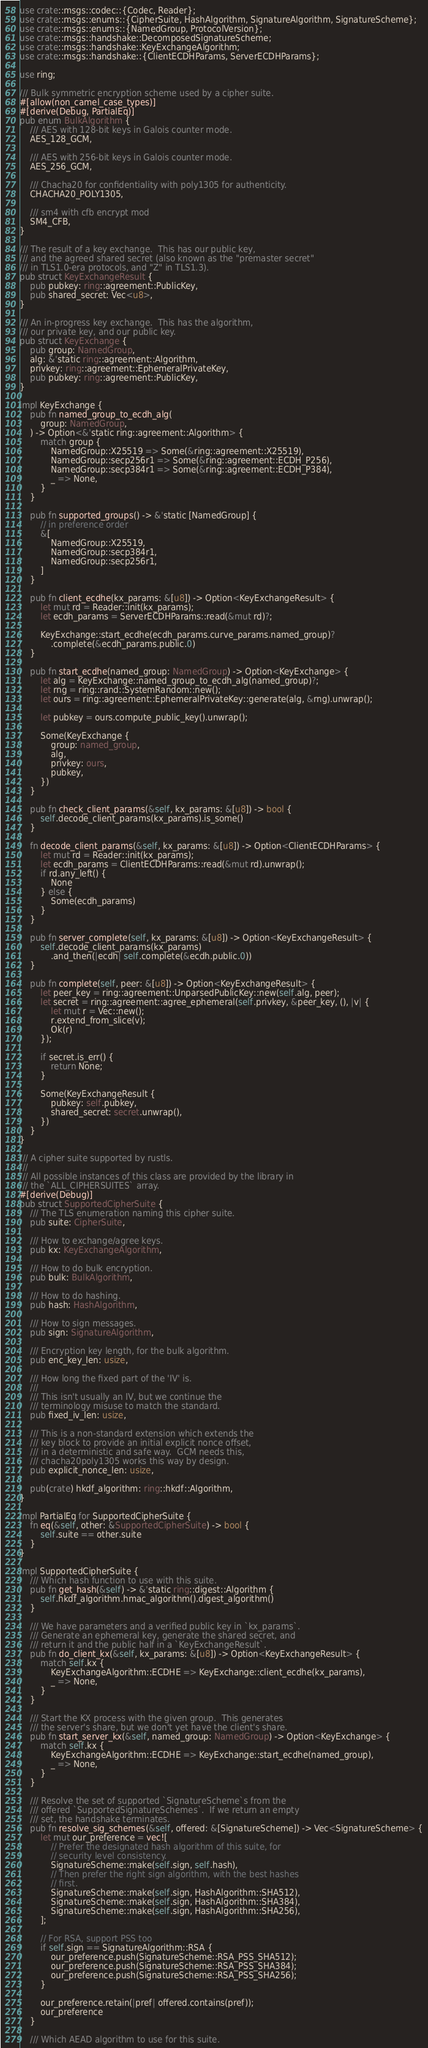Convert code to text. <code><loc_0><loc_0><loc_500><loc_500><_Rust_>use crate::msgs::codec::{Codec, Reader};
use crate::msgs::enums::{CipherSuite, HashAlgorithm, SignatureAlgorithm, SignatureScheme};
use crate::msgs::enums::{NamedGroup, ProtocolVersion};
use crate::msgs::handshake::DecomposedSignatureScheme;
use crate::msgs::handshake::KeyExchangeAlgorithm;
use crate::msgs::handshake::{ClientECDHParams, ServerECDHParams};

use ring;

/// Bulk symmetric encryption scheme used by a cipher suite.
#[allow(non_camel_case_types)]
#[derive(Debug, PartialEq)]
pub enum BulkAlgorithm {
    /// AES with 128-bit keys in Galois counter mode.
    AES_128_GCM,

    /// AES with 256-bit keys in Galois counter mode.
    AES_256_GCM,

    /// Chacha20 for confidentiality with poly1305 for authenticity.
    CHACHA20_POLY1305,

    /// sm4 with cfb encrypt mod
    SM4_CFB,
}

/// The result of a key exchange.  This has our public key,
/// and the agreed shared secret (also known as the "premaster secret"
/// in TLS1.0-era protocols, and "Z" in TLS1.3).
pub struct KeyExchangeResult {
    pub pubkey: ring::agreement::PublicKey,
    pub shared_secret: Vec<u8>,
}

/// An in-progress key exchange.  This has the algorithm,
/// our private key, and our public key.
pub struct KeyExchange {
    pub group: NamedGroup,
    alg: &'static ring::agreement::Algorithm,
    privkey: ring::agreement::EphemeralPrivateKey,
    pub pubkey: ring::agreement::PublicKey,
}

impl KeyExchange {
    pub fn named_group_to_ecdh_alg(
        group: NamedGroup,
    ) -> Option<&'static ring::agreement::Algorithm> {
        match group {
            NamedGroup::X25519 => Some(&ring::agreement::X25519),
            NamedGroup::secp256r1 => Some(&ring::agreement::ECDH_P256),
            NamedGroup::secp384r1 => Some(&ring::agreement::ECDH_P384),
            _ => None,
        }
    }

    pub fn supported_groups() -> &'static [NamedGroup] {
        // in preference order
        &[
            NamedGroup::X25519,
            NamedGroup::secp384r1,
            NamedGroup::secp256r1,
        ]
    }

    pub fn client_ecdhe(kx_params: &[u8]) -> Option<KeyExchangeResult> {
        let mut rd = Reader::init(kx_params);
        let ecdh_params = ServerECDHParams::read(&mut rd)?;

        KeyExchange::start_ecdhe(ecdh_params.curve_params.named_group)?
            .complete(&ecdh_params.public.0)
    }

    pub fn start_ecdhe(named_group: NamedGroup) -> Option<KeyExchange> {
        let alg = KeyExchange::named_group_to_ecdh_alg(named_group)?;
        let rng = ring::rand::SystemRandom::new();
        let ours = ring::agreement::EphemeralPrivateKey::generate(alg, &rng).unwrap();

        let pubkey = ours.compute_public_key().unwrap();

        Some(KeyExchange {
            group: named_group,
            alg,
            privkey: ours,
            pubkey,
        })
    }

    pub fn check_client_params(&self, kx_params: &[u8]) -> bool {
        self.decode_client_params(kx_params).is_some()
    }

    fn decode_client_params(&self, kx_params: &[u8]) -> Option<ClientECDHParams> {
        let mut rd = Reader::init(kx_params);
        let ecdh_params = ClientECDHParams::read(&mut rd).unwrap();
        if rd.any_left() {
            None
        } else {
            Some(ecdh_params)
        }
    }

    pub fn server_complete(self, kx_params: &[u8]) -> Option<KeyExchangeResult> {
        self.decode_client_params(kx_params)
            .and_then(|ecdh| self.complete(&ecdh.public.0))
    }

    pub fn complete(self, peer: &[u8]) -> Option<KeyExchangeResult> {
        let peer_key = ring::agreement::UnparsedPublicKey::new(self.alg, peer);
        let secret = ring::agreement::agree_ephemeral(self.privkey, &peer_key, (), |v| {
            let mut r = Vec::new();
            r.extend_from_slice(v);
            Ok(r)
        });

        if secret.is_err() {
            return None;
        }

        Some(KeyExchangeResult {
            pubkey: self.pubkey,
            shared_secret: secret.unwrap(),
        })
    }
}

/// A cipher suite supported by rustls.
///
/// All possible instances of this class are provided by the library in
/// the `ALL_CIPHERSUITES` array.
#[derive(Debug)]
pub struct SupportedCipherSuite {
    /// The TLS enumeration naming this cipher suite.
    pub suite: CipherSuite,

    /// How to exchange/agree keys.
    pub kx: KeyExchangeAlgorithm,

    /// How to do bulk encryption.
    pub bulk: BulkAlgorithm,

    /// How to do hashing.
    pub hash: HashAlgorithm,

    /// How to sign messages.
    pub sign: SignatureAlgorithm,

    /// Encryption key length, for the bulk algorithm.
    pub enc_key_len: usize,

    /// How long the fixed part of the 'IV' is.
    ///
    /// This isn't usually an IV, but we continue the
    /// terminology misuse to match the standard.
    pub fixed_iv_len: usize,

    /// This is a non-standard extension which extends the
    /// key block to provide an initial explicit nonce offset,
    /// in a deterministic and safe way.  GCM needs this,
    /// chacha20poly1305 works this way by design.
    pub explicit_nonce_len: usize,

    pub(crate) hkdf_algorithm: ring::hkdf::Algorithm,
}

impl PartialEq for SupportedCipherSuite {
    fn eq(&self, other: &SupportedCipherSuite) -> bool {
        self.suite == other.suite
    }
}

impl SupportedCipherSuite {
    /// Which hash function to use with this suite.
    pub fn get_hash(&self) -> &'static ring::digest::Algorithm {
        self.hkdf_algorithm.hmac_algorithm().digest_algorithm()
    }

    /// We have parameters and a verified public key in `kx_params`.
    /// Generate an ephemeral key, generate the shared secret, and
    /// return it and the public half in a `KeyExchangeResult`.
    pub fn do_client_kx(&self, kx_params: &[u8]) -> Option<KeyExchangeResult> {
        match self.kx {
            KeyExchangeAlgorithm::ECDHE => KeyExchange::client_ecdhe(kx_params),
            _ => None,
        }
    }

    /// Start the KX process with the given group.  This generates
    /// the server's share, but we don't yet have the client's share.
    pub fn start_server_kx(&self, named_group: NamedGroup) -> Option<KeyExchange> {
        match self.kx {
            KeyExchangeAlgorithm::ECDHE => KeyExchange::start_ecdhe(named_group),
            _ => None,
        }
    }

    /// Resolve the set of supported `SignatureScheme`s from the
    /// offered `SupportedSignatureSchemes`.  If we return an empty
    /// set, the handshake terminates.
    pub fn resolve_sig_schemes(&self, offered: &[SignatureScheme]) -> Vec<SignatureScheme> {
        let mut our_preference = vec![
            // Prefer the designated hash algorithm of this suite, for
            // security level consistency.
            SignatureScheme::make(self.sign, self.hash),
            // Then prefer the right sign algorithm, with the best hashes
            // first.
            SignatureScheme::make(self.sign, HashAlgorithm::SHA512),
            SignatureScheme::make(self.sign, HashAlgorithm::SHA384),
            SignatureScheme::make(self.sign, HashAlgorithm::SHA256),
        ];

        // For RSA, support PSS too
        if self.sign == SignatureAlgorithm::RSA {
            our_preference.push(SignatureScheme::RSA_PSS_SHA512);
            our_preference.push(SignatureScheme::RSA_PSS_SHA384);
            our_preference.push(SignatureScheme::RSA_PSS_SHA256);
        }

        our_preference.retain(|pref| offered.contains(pref));
        our_preference
    }

    /// Which AEAD algorithm to use for this suite.</code> 